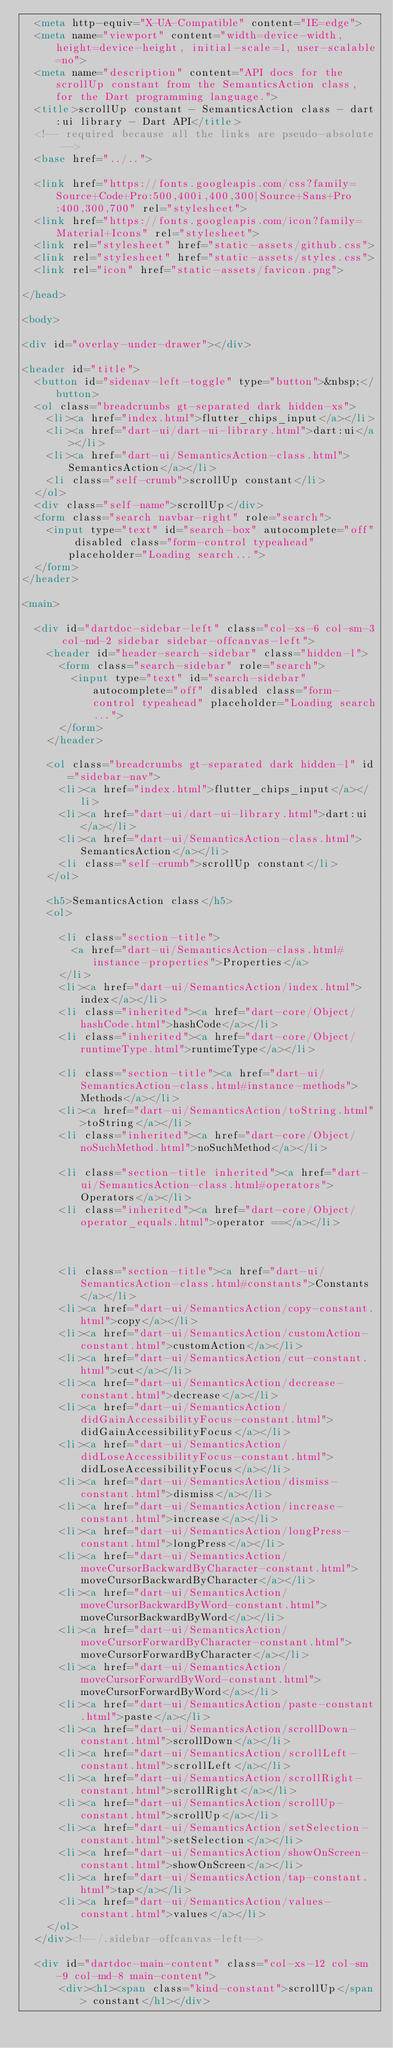<code> <loc_0><loc_0><loc_500><loc_500><_HTML_>  <meta http-equiv="X-UA-Compatible" content="IE=edge">
  <meta name="viewport" content="width=device-width, height=device-height, initial-scale=1, user-scalable=no">
  <meta name="description" content="API docs for the scrollUp constant from the SemanticsAction class, for the Dart programming language.">
  <title>scrollUp constant - SemanticsAction class - dart:ui library - Dart API</title>
  <!-- required because all the links are pseudo-absolute -->
  <base href="../..">

  <link href="https://fonts.googleapis.com/css?family=Source+Code+Pro:500,400i,400,300|Source+Sans+Pro:400,300,700" rel="stylesheet">
  <link href="https://fonts.googleapis.com/icon?family=Material+Icons" rel="stylesheet">
  <link rel="stylesheet" href="static-assets/github.css">
  <link rel="stylesheet" href="static-assets/styles.css">
  <link rel="icon" href="static-assets/favicon.png">
  
</head>

<body>

<div id="overlay-under-drawer"></div>

<header id="title">
  <button id="sidenav-left-toggle" type="button">&nbsp;</button>
  <ol class="breadcrumbs gt-separated dark hidden-xs">
    <li><a href="index.html">flutter_chips_input</a></li>
    <li><a href="dart-ui/dart-ui-library.html">dart:ui</a></li>
    <li><a href="dart-ui/SemanticsAction-class.html">SemanticsAction</a></li>
    <li class="self-crumb">scrollUp constant</li>
  </ol>
  <div class="self-name">scrollUp</div>
  <form class="search navbar-right" role="search">
    <input type="text" id="search-box" autocomplete="off" disabled class="form-control typeahead" placeholder="Loading search...">
  </form>
</header>

<main>

  <div id="dartdoc-sidebar-left" class="col-xs-6 col-sm-3 col-md-2 sidebar sidebar-offcanvas-left">
    <header id="header-search-sidebar" class="hidden-l">
      <form class="search-sidebar" role="search">
        <input type="text" id="search-sidebar" autocomplete="off" disabled class="form-control typeahead" placeholder="Loading search...">
      </form>
    </header>
    
    <ol class="breadcrumbs gt-separated dark hidden-l" id="sidebar-nav">
      <li><a href="index.html">flutter_chips_input</a></li>
      <li><a href="dart-ui/dart-ui-library.html">dart:ui</a></li>
      <li><a href="dart-ui/SemanticsAction-class.html">SemanticsAction</a></li>
      <li class="self-crumb">scrollUp constant</li>
    </ol>
    
    <h5>SemanticsAction class</h5>
    <ol>
    
      <li class="section-title">
        <a href="dart-ui/SemanticsAction-class.html#instance-properties">Properties</a>
      </li>
      <li><a href="dart-ui/SemanticsAction/index.html">index</a></li>
      <li class="inherited"><a href="dart-core/Object/hashCode.html">hashCode</a></li>
      <li class="inherited"><a href="dart-core/Object/runtimeType.html">runtimeType</a></li>
    
      <li class="section-title"><a href="dart-ui/SemanticsAction-class.html#instance-methods">Methods</a></li>
      <li><a href="dart-ui/SemanticsAction/toString.html">toString</a></li>
      <li class="inherited"><a href="dart-core/Object/noSuchMethod.html">noSuchMethod</a></li>
    
      <li class="section-title inherited"><a href="dart-ui/SemanticsAction-class.html#operators">Operators</a></li>
      <li class="inherited"><a href="dart-core/Object/operator_equals.html">operator ==</a></li>
    
    
    
      <li class="section-title"><a href="dart-ui/SemanticsAction-class.html#constants">Constants</a></li>
      <li><a href="dart-ui/SemanticsAction/copy-constant.html">copy</a></li>
      <li><a href="dart-ui/SemanticsAction/customAction-constant.html">customAction</a></li>
      <li><a href="dart-ui/SemanticsAction/cut-constant.html">cut</a></li>
      <li><a href="dart-ui/SemanticsAction/decrease-constant.html">decrease</a></li>
      <li><a href="dart-ui/SemanticsAction/didGainAccessibilityFocus-constant.html">didGainAccessibilityFocus</a></li>
      <li><a href="dart-ui/SemanticsAction/didLoseAccessibilityFocus-constant.html">didLoseAccessibilityFocus</a></li>
      <li><a href="dart-ui/SemanticsAction/dismiss-constant.html">dismiss</a></li>
      <li><a href="dart-ui/SemanticsAction/increase-constant.html">increase</a></li>
      <li><a href="dart-ui/SemanticsAction/longPress-constant.html">longPress</a></li>
      <li><a href="dart-ui/SemanticsAction/moveCursorBackwardByCharacter-constant.html">moveCursorBackwardByCharacter</a></li>
      <li><a href="dart-ui/SemanticsAction/moveCursorBackwardByWord-constant.html">moveCursorBackwardByWord</a></li>
      <li><a href="dart-ui/SemanticsAction/moveCursorForwardByCharacter-constant.html">moveCursorForwardByCharacter</a></li>
      <li><a href="dart-ui/SemanticsAction/moveCursorForwardByWord-constant.html">moveCursorForwardByWord</a></li>
      <li><a href="dart-ui/SemanticsAction/paste-constant.html">paste</a></li>
      <li><a href="dart-ui/SemanticsAction/scrollDown-constant.html">scrollDown</a></li>
      <li><a href="dart-ui/SemanticsAction/scrollLeft-constant.html">scrollLeft</a></li>
      <li><a href="dart-ui/SemanticsAction/scrollRight-constant.html">scrollRight</a></li>
      <li><a href="dart-ui/SemanticsAction/scrollUp-constant.html">scrollUp</a></li>
      <li><a href="dart-ui/SemanticsAction/setSelection-constant.html">setSelection</a></li>
      <li><a href="dart-ui/SemanticsAction/showOnScreen-constant.html">showOnScreen</a></li>
      <li><a href="dart-ui/SemanticsAction/tap-constant.html">tap</a></li>
      <li><a href="dart-ui/SemanticsAction/values-constant.html">values</a></li>
    </ol>
  </div><!--/.sidebar-offcanvas-left-->

  <div id="dartdoc-main-content" class="col-xs-12 col-sm-9 col-md-8 main-content">
      <div><h1><span class="kind-constant">scrollUp</span> constant</h1></div>
</code> 